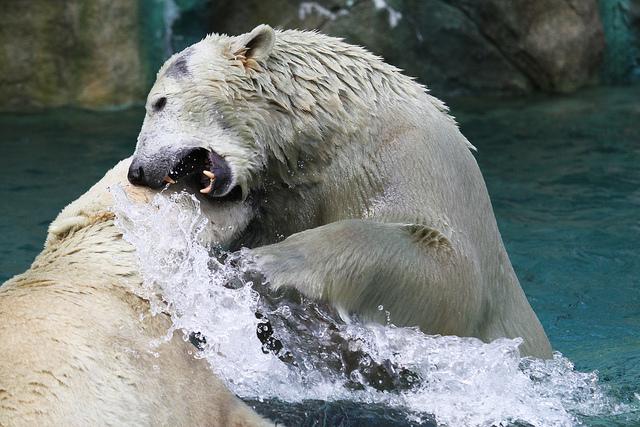Does the bear look friendly?
Keep it brief. No. Is the animal on dry land?
Be succinct. No. What type of animals is this?
Answer briefly. Polar bear. Is the bear wet or dry?
Answer briefly. Wet. 